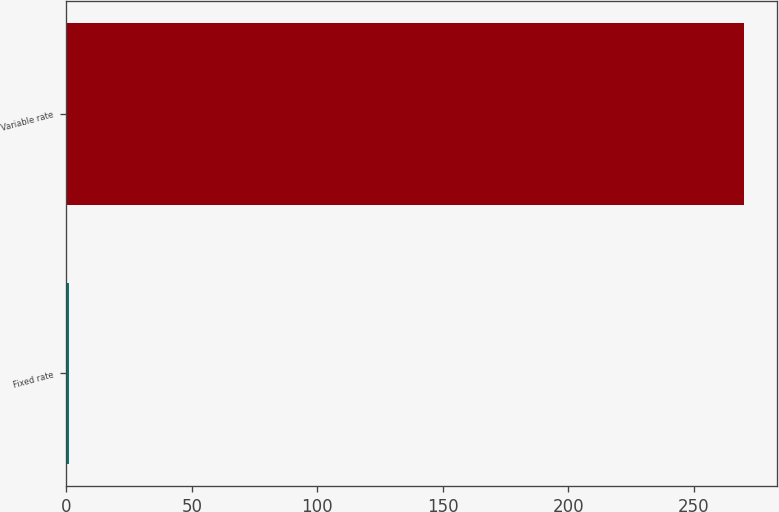Convert chart to OTSL. <chart><loc_0><loc_0><loc_500><loc_500><bar_chart><fcel>Fixed rate<fcel>Variable rate<nl><fcel>0.9<fcel>269.9<nl></chart> 